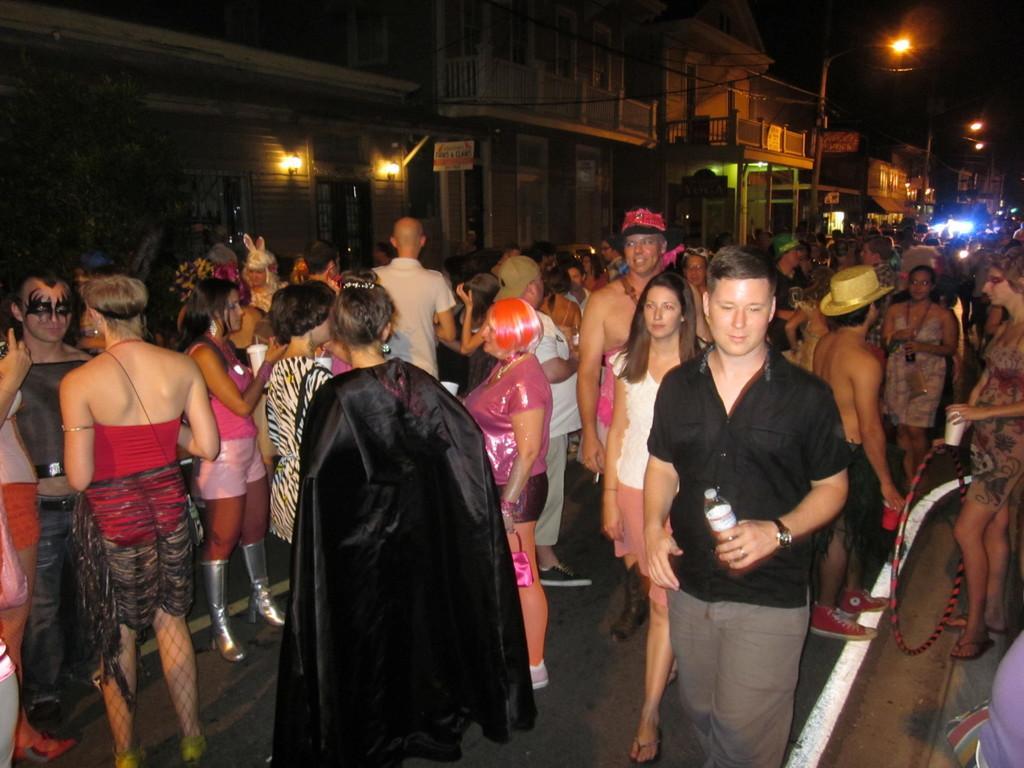Describe this image in one or two sentences. This is an image clicked in the dark. Here I can see a crowd of people standing on the road. In the background there are many buildings and also I can see light poles. 